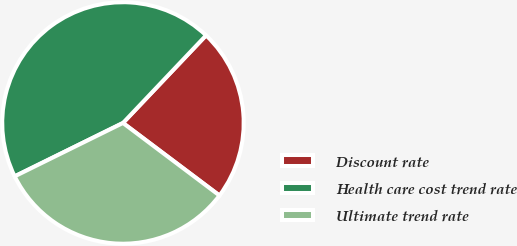Convert chart. <chart><loc_0><loc_0><loc_500><loc_500><pie_chart><fcel>Discount rate<fcel>Health care cost trend rate<fcel>Ultimate trend rate<nl><fcel>23.18%<fcel>44.37%<fcel>32.45%<nl></chart> 